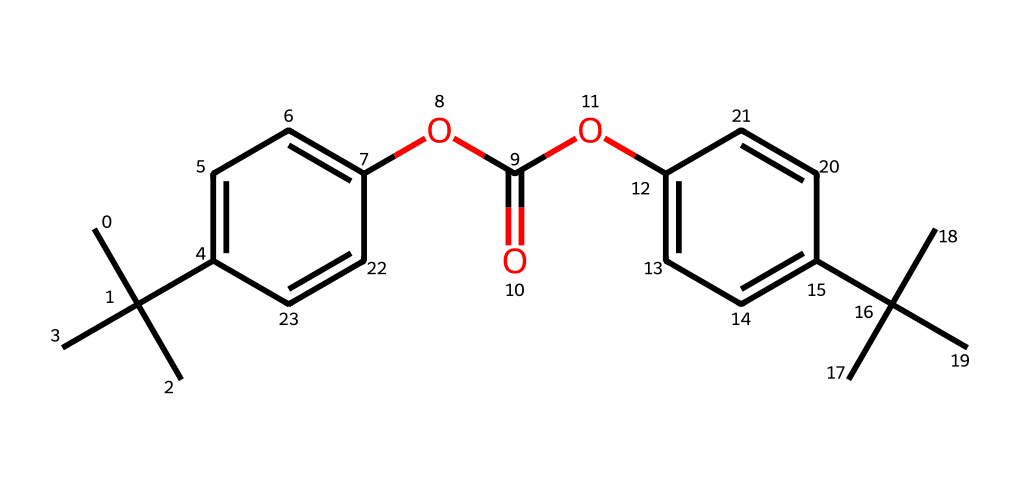What is the main functional group present in the chemical structure? The structure contains the ester group, characterized by the -OC(=O)- section. This identifies it as a polycarbonate with ester linkages.
Answer: ester How many carbon atoms are in the structure? By counting the explicit carbon atoms in the SMILES representation, including the tertiary butyl groups, the total is 18 carbon atoms.
Answer: 18 What type of polymer is this compound classified as? The compound is classified as a polycarbonate, which is indicated by the arrangement of the repeating ester linkages within the structure.
Answer: polycarbonate What properties might the presence of bulky substituents confer to the polymer? The bulky substituents (tertiary butyl groups) increase steric hindrance, leading to increased toughness and impact resistance of the polymer.
Answer: toughness How many aromatic rings are present in the structure? There are two aromatic rings observable from the structure, as seen in the two benzene-like rings in the chemical representation.
Answer: 2 What does the presence of the methoxy group suggest about the chemical's properties? The methoxy group (-OCH3) can enhance solubility in organic solvents and potentially affects the thermal and optical properties of the polymer.
Answer: solubility 